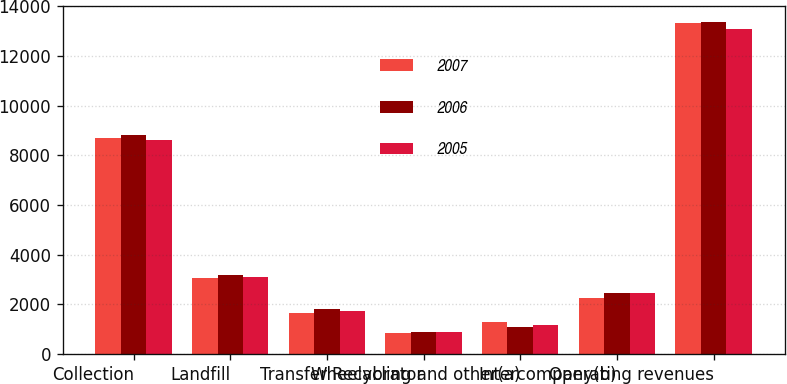Convert chart to OTSL. <chart><loc_0><loc_0><loc_500><loc_500><stacked_bar_chart><ecel><fcel>Collection<fcel>Landfill<fcel>Transfer<fcel>Wheelabrator<fcel>Recycling and other(a)<fcel>Intercompany(b)<fcel>Operating revenues<nl><fcel>2007<fcel>8714<fcel>3047<fcel>1654<fcel>868<fcel>1298<fcel>2271<fcel>13310<nl><fcel>2006<fcel>8837<fcel>3197<fcel>1802<fcel>902<fcel>1074<fcel>2449<fcel>13363<nl><fcel>2005<fcel>8633<fcel>3089<fcel>1756<fcel>879<fcel>1183<fcel>2466<fcel>13074<nl></chart> 